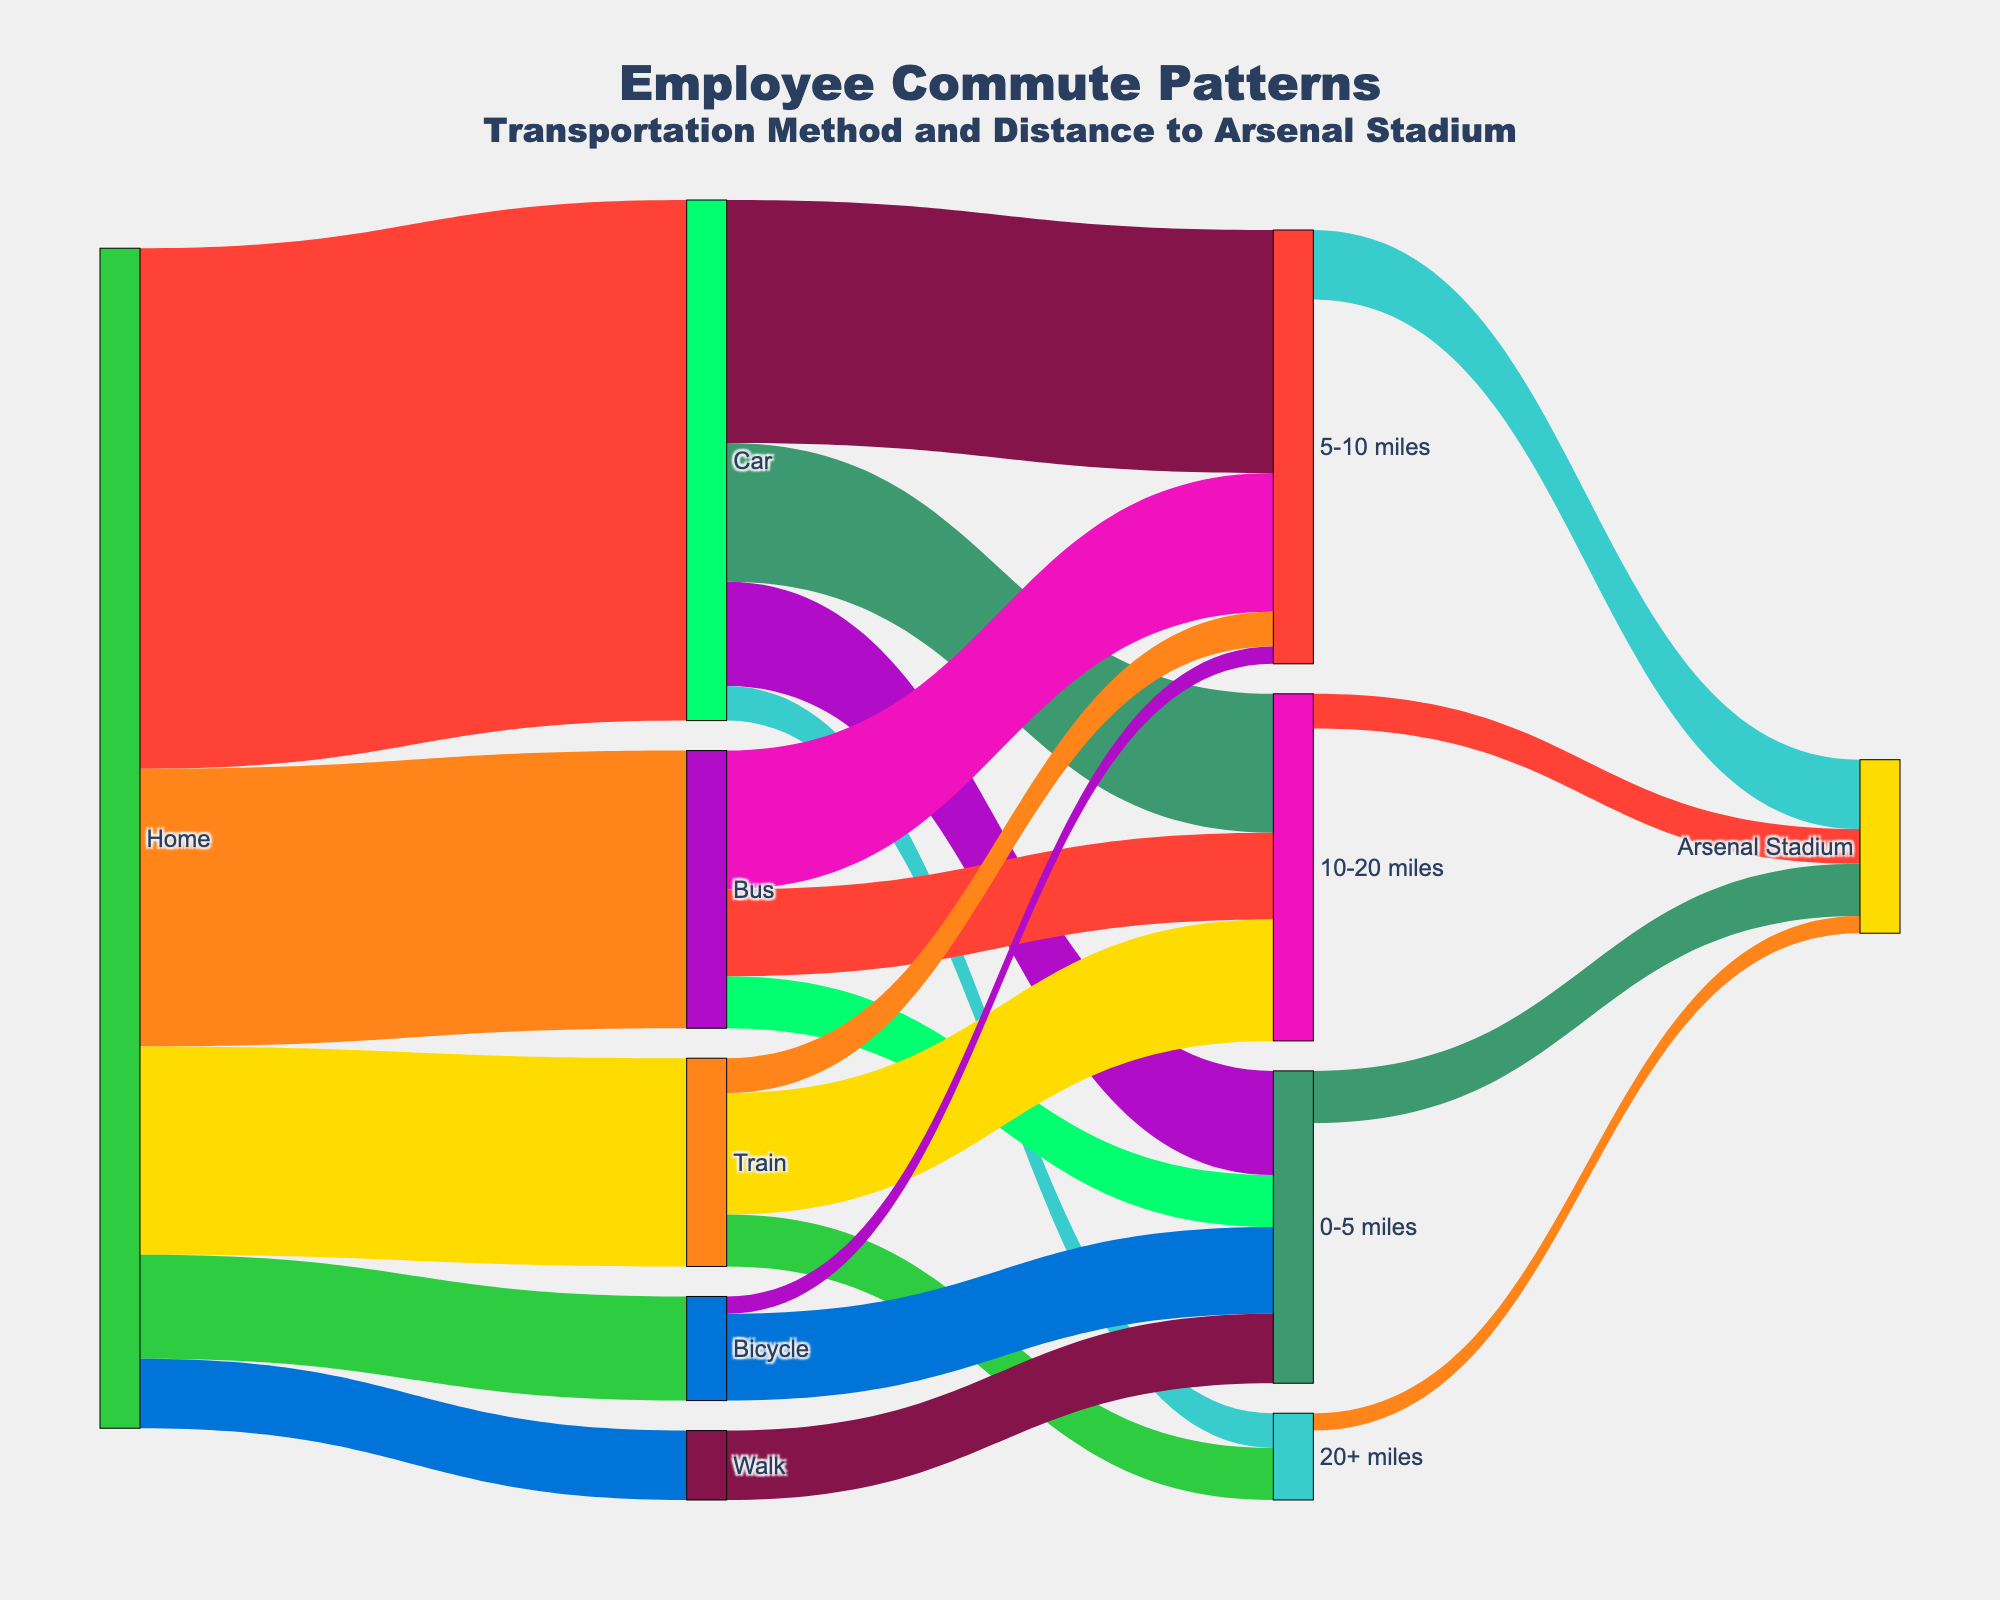What's the most common transportation method for employees commuting from home to work? The widest link originating from "Home" indicates the most common transportation method. The "Car" link is the widest, indicating that most employees use cars.
Answer: Car How many employees commute by bus to work? The link between "Home" and "Bus" shows the number of employees commuting by bus. By looking at the width of the link and values, we can see it's 80 employees.
Answer: 80 What distance interval has the highest number of car commuters? To find this, we examine the links branching from "Car" to different distance intervals. The link to "5-10 miles" appears the widest and its value is 70.
Answer: 5-10 miles How many employees cycle more than 5 miles to work? We need to find the employees using "Bicycle" and commute "0-5 miles" and "5-10 miles". Only "0-5 miles" link is present with a value of 25, so 5 will cycle more than 5 miles.
Answer: 5 Which transportation method has the smallest number of employees? By comparing the values of links coming from "Home" to different modes, "Walk" has the smallest link value of 20.
Answer: Walk How many total employees commute 0-5 miles regardless of the transportation method? Sum the values of all links leading to "0-5 miles": For Car (30), Bus (15), Bicycle (25), and Walk (20). Summing them gives 30+15+25+20=90.
Answer: 90 Which distance interval has the lowest number of employees reaching Arsenal Stadium? Compare the values of links leading to "Arsenal Stadium" across the different distance intervals. The "20+ miles" has the smallest value at 5.
Answer: 20+ miles How many employees take both bus and train for distances between 10-20 miles? The links from "Bus" to "10-20 miles" (25) and "Train" to "10-20 miles" (35) sum up as 25+35=60 employees.
Answer: 60 What's the total number of employees commuting by environmentally friendly means (Bicycle and Walk)? Sum the values of links from "Home" to "Bicycle" and "Walk". Bicycle is 30 and Walk is 20, so 30+20=50 employees.
Answer: 50 What's the percentage of car commuters traveling more than 10 miles? Calculate the sum of car commuters going 10-20 miles (40) and 20+ miles (10). In total is 40+10=50. Divide by total car commuters (150) and then multiply by 100: (50/150)*100=33.33%.
Answer: 33.33% 